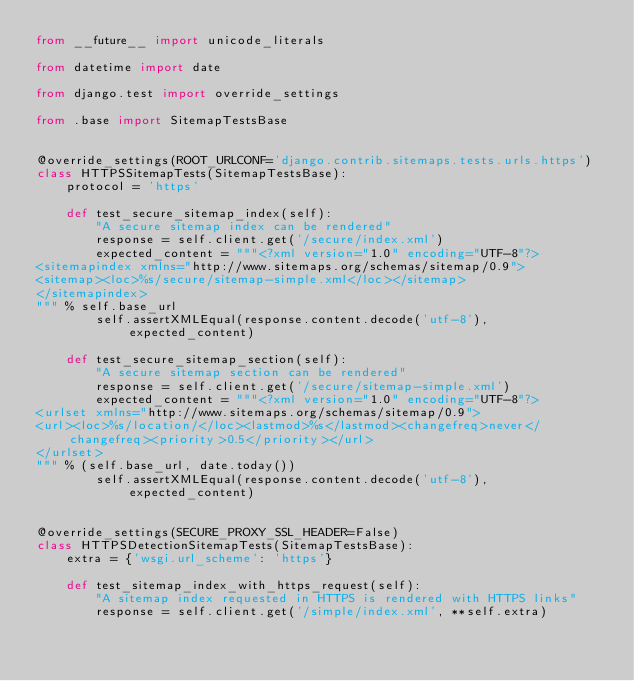Convert code to text. <code><loc_0><loc_0><loc_500><loc_500><_Python_>from __future__ import unicode_literals

from datetime import date

from django.test import override_settings

from .base import SitemapTestsBase


@override_settings(ROOT_URLCONF='django.contrib.sitemaps.tests.urls.https')
class HTTPSSitemapTests(SitemapTestsBase):
    protocol = 'https'

    def test_secure_sitemap_index(self):
        "A secure sitemap index can be rendered"
        response = self.client.get('/secure/index.xml')
        expected_content = """<?xml version="1.0" encoding="UTF-8"?>
<sitemapindex xmlns="http://www.sitemaps.org/schemas/sitemap/0.9">
<sitemap><loc>%s/secure/sitemap-simple.xml</loc></sitemap>
</sitemapindex>
""" % self.base_url
        self.assertXMLEqual(response.content.decode('utf-8'), expected_content)

    def test_secure_sitemap_section(self):
        "A secure sitemap section can be rendered"
        response = self.client.get('/secure/sitemap-simple.xml')
        expected_content = """<?xml version="1.0" encoding="UTF-8"?>
<urlset xmlns="http://www.sitemaps.org/schemas/sitemap/0.9">
<url><loc>%s/location/</loc><lastmod>%s</lastmod><changefreq>never</changefreq><priority>0.5</priority></url>
</urlset>
""" % (self.base_url, date.today())
        self.assertXMLEqual(response.content.decode('utf-8'), expected_content)


@override_settings(SECURE_PROXY_SSL_HEADER=False)
class HTTPSDetectionSitemapTests(SitemapTestsBase):
    extra = {'wsgi.url_scheme': 'https'}

    def test_sitemap_index_with_https_request(self):
        "A sitemap index requested in HTTPS is rendered with HTTPS links"
        response = self.client.get('/simple/index.xml', **self.extra)</code> 